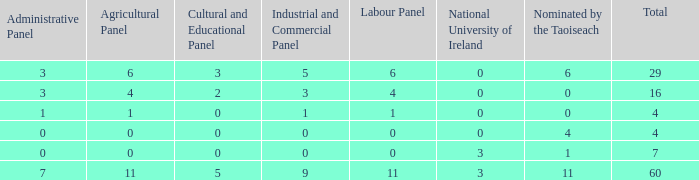What is the highest number of nominations by Taoiseach of the composition with an administrative panel greater than 0 and an industrial and commercial panel less than 1? None. 